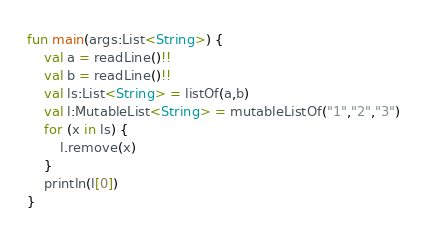<code> <loc_0><loc_0><loc_500><loc_500><_Kotlin_>fun main(args:List<String>) {
    val a = readLine()!!
    val b = readLine()!!
    val ls:List<String> = listOf(a,b)
    val l:MutableList<String> = mutableListOf("1","2","3")
    for (x in ls) {
        l.remove(x)
    }
    println(l[0])
}
</code> 